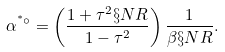<formula> <loc_0><loc_0><loc_500><loc_500>\alpha ^ { ^ { * } \circ } = \left ( \frac { 1 + \tau ^ { 2 } \S N R } { 1 - \tau ^ { 2 } } \right ) \frac { 1 } { \beta \S N R } .</formula> 